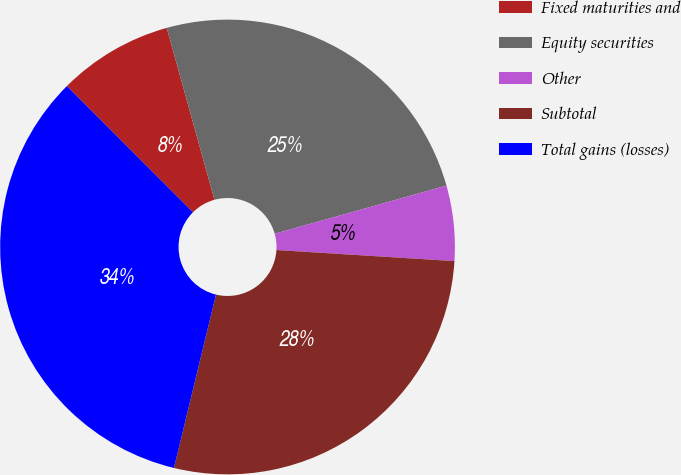Convert chart to OTSL. <chart><loc_0><loc_0><loc_500><loc_500><pie_chart><fcel>Fixed maturities and<fcel>Equity securities<fcel>Other<fcel>Subtotal<fcel>Total gains (losses)<nl><fcel>8.18%<fcel>24.96%<fcel>5.34%<fcel>27.8%<fcel>33.73%<nl></chart> 